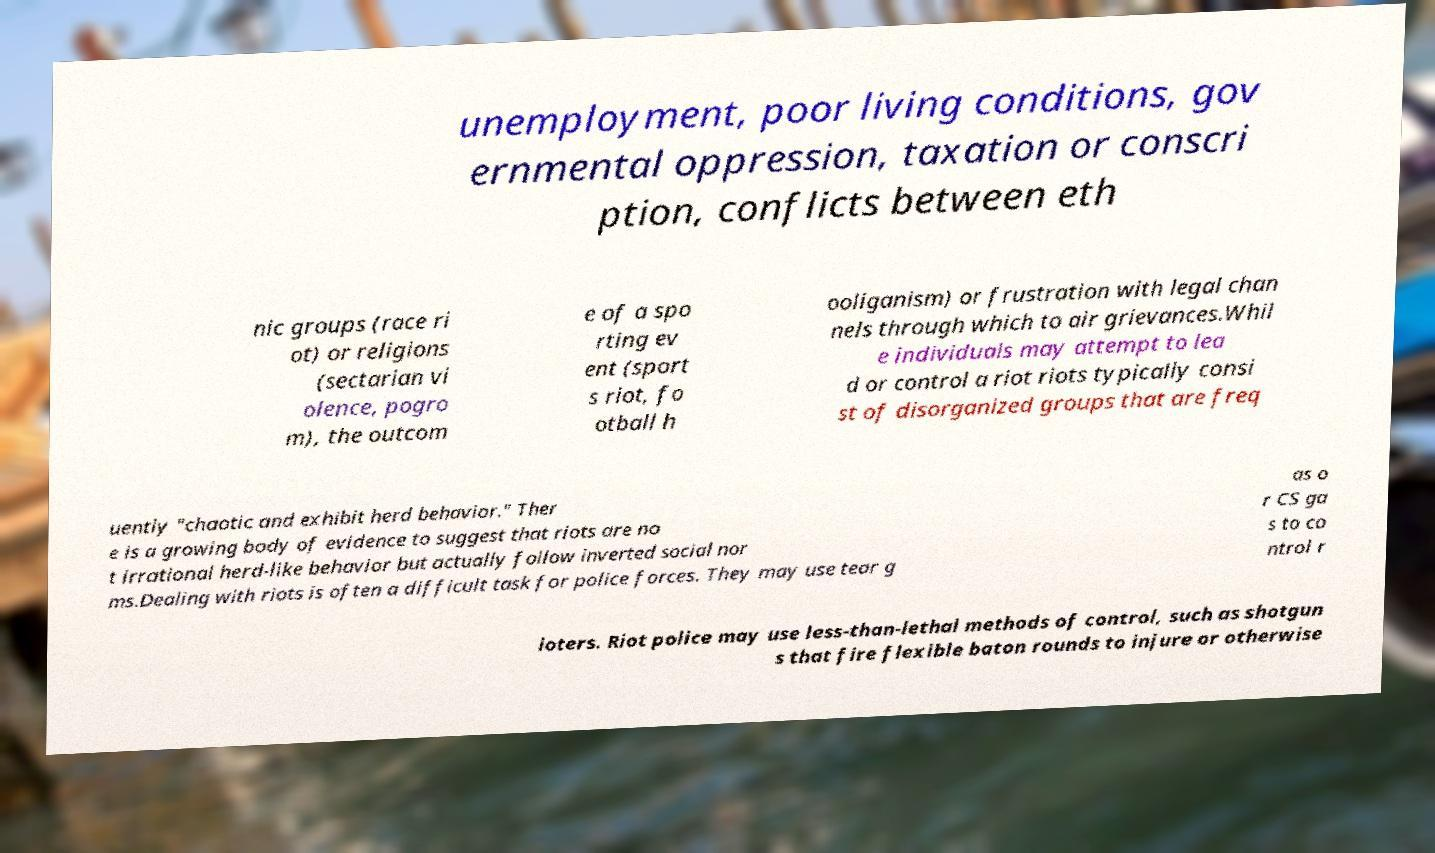Please read and relay the text visible in this image. What does it say? unemployment, poor living conditions, gov ernmental oppression, taxation or conscri ption, conflicts between eth nic groups (race ri ot) or religions (sectarian vi olence, pogro m), the outcom e of a spo rting ev ent (sport s riot, fo otball h ooliganism) or frustration with legal chan nels through which to air grievances.Whil e individuals may attempt to lea d or control a riot riots typically consi st of disorganized groups that are freq uently "chaotic and exhibit herd behavior." Ther e is a growing body of evidence to suggest that riots are no t irrational herd-like behavior but actually follow inverted social nor ms.Dealing with riots is often a difficult task for police forces. They may use tear g as o r CS ga s to co ntrol r ioters. Riot police may use less-than-lethal methods of control, such as shotgun s that fire flexible baton rounds to injure or otherwise 